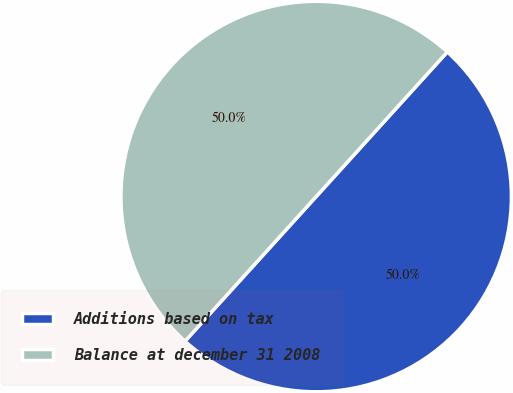Convert chart. <chart><loc_0><loc_0><loc_500><loc_500><pie_chart><fcel>Additions based on tax<fcel>Balance at december 31 2008<nl><fcel>50.0%<fcel>50.0%<nl></chart> 